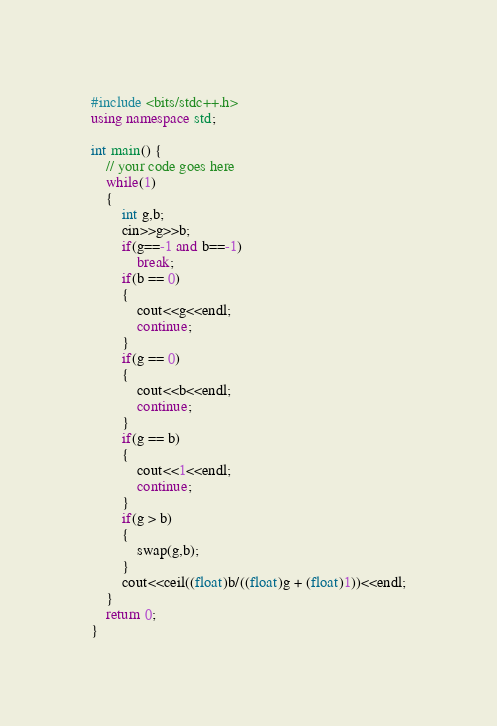<code> <loc_0><loc_0><loc_500><loc_500><_C++_>#include <bits/stdc++.h>
using namespace std;

int main() {
	// your code goes here
	while(1)
	{
		int g,b;
		cin>>g>>b;
		if(g==-1 and b==-1)
			break;
		if(b == 0)
		{
			cout<<g<<endl;
			continue;
		}
		if(g == 0)
		{
			cout<<b<<endl;
			continue;
		}
		if(g == b)
		{
			cout<<1<<endl;
			continue;
		}	
		if(g > b)
		{
			swap(g,b);
		}	
		cout<<ceil((float)b/((float)g + (float)1))<<endl;
	}
	return 0;
}</code> 